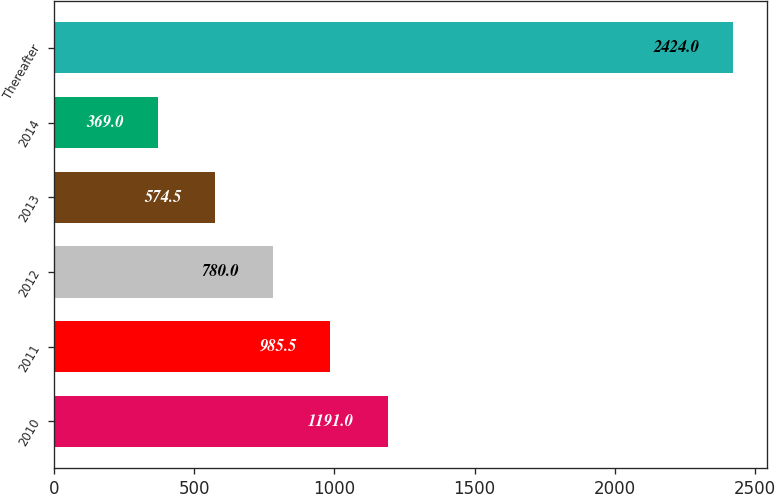Convert chart to OTSL. <chart><loc_0><loc_0><loc_500><loc_500><bar_chart><fcel>2010<fcel>2011<fcel>2012<fcel>2013<fcel>2014<fcel>Thereafter<nl><fcel>1191<fcel>985.5<fcel>780<fcel>574.5<fcel>369<fcel>2424<nl></chart> 